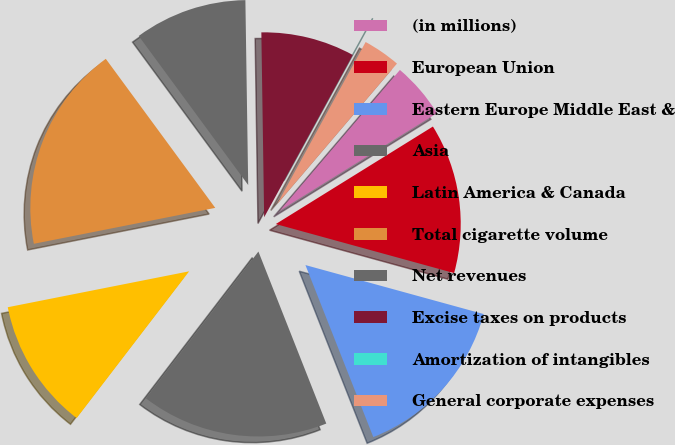Convert chart to OTSL. <chart><loc_0><loc_0><loc_500><loc_500><pie_chart><fcel>(in millions)<fcel>European Union<fcel>Eastern Europe Middle East &<fcel>Asia<fcel>Latin America & Canada<fcel>Total cigarette volume<fcel>Net revenues<fcel>Excise taxes on products<fcel>Amortization of intangibles<fcel>General corporate expenses<nl><fcel>4.92%<fcel>13.11%<fcel>14.75%<fcel>16.39%<fcel>11.48%<fcel>18.03%<fcel>9.84%<fcel>8.2%<fcel>0.0%<fcel>3.28%<nl></chart> 